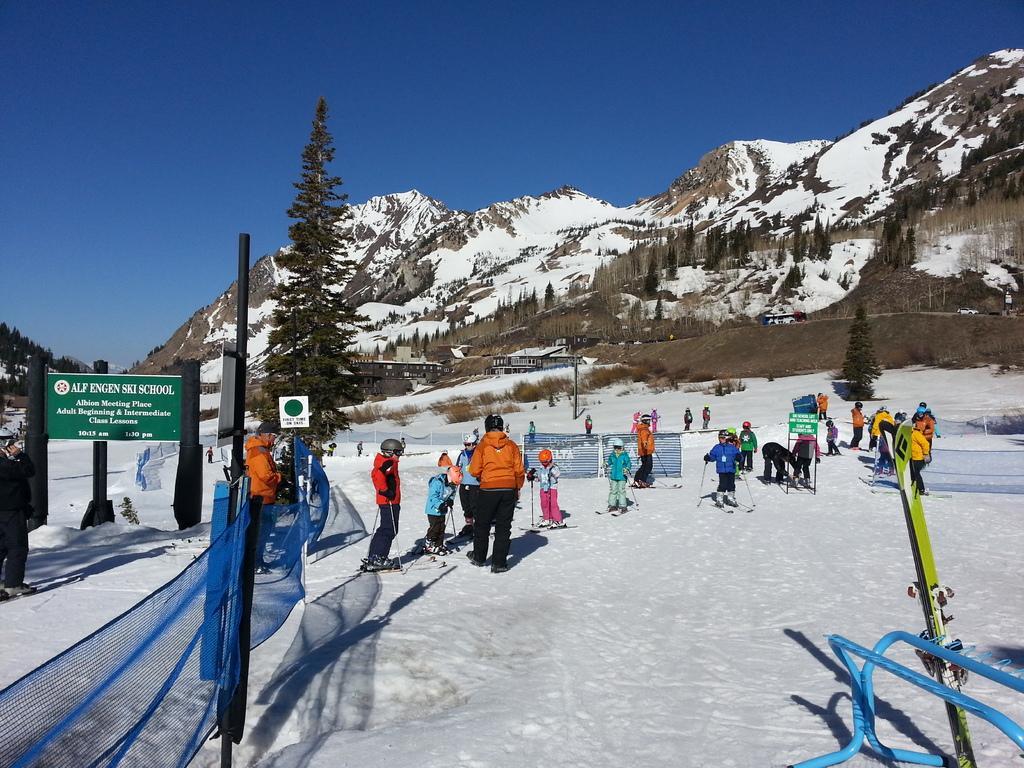How would you summarize this image in a sentence or two? There are group of people skating in the snow and there are mountains and trees covered with snow in the background and the sky is blue in color. 